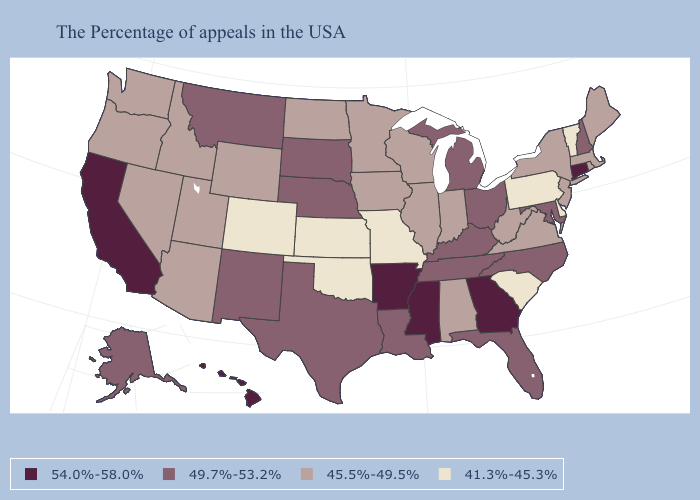Among the states that border Michigan , does Indiana have the lowest value?
Write a very short answer. Yes. Does West Virginia have the lowest value in the South?
Short answer required. No. What is the value of Massachusetts?
Quick response, please. 45.5%-49.5%. Which states have the highest value in the USA?
Answer briefly. Connecticut, Georgia, Mississippi, Arkansas, California, Hawaii. What is the value of Illinois?
Write a very short answer. 45.5%-49.5%. Does the first symbol in the legend represent the smallest category?
Quick response, please. No. How many symbols are there in the legend?
Be succinct. 4. What is the lowest value in states that border North Carolina?
Write a very short answer. 41.3%-45.3%. Name the states that have a value in the range 49.7%-53.2%?
Concise answer only. New Hampshire, Maryland, North Carolina, Ohio, Florida, Michigan, Kentucky, Tennessee, Louisiana, Nebraska, Texas, South Dakota, New Mexico, Montana, Alaska. Among the states that border New York , which have the highest value?
Give a very brief answer. Connecticut. Name the states that have a value in the range 45.5%-49.5%?
Keep it brief. Maine, Massachusetts, Rhode Island, New York, New Jersey, Virginia, West Virginia, Indiana, Alabama, Wisconsin, Illinois, Minnesota, Iowa, North Dakota, Wyoming, Utah, Arizona, Idaho, Nevada, Washington, Oregon. How many symbols are there in the legend?
Quick response, please. 4. Name the states that have a value in the range 41.3%-45.3%?
Give a very brief answer. Vermont, Delaware, Pennsylvania, South Carolina, Missouri, Kansas, Oklahoma, Colorado. Name the states that have a value in the range 45.5%-49.5%?
Give a very brief answer. Maine, Massachusetts, Rhode Island, New York, New Jersey, Virginia, West Virginia, Indiana, Alabama, Wisconsin, Illinois, Minnesota, Iowa, North Dakota, Wyoming, Utah, Arizona, Idaho, Nevada, Washington, Oregon. How many symbols are there in the legend?
Answer briefly. 4. 